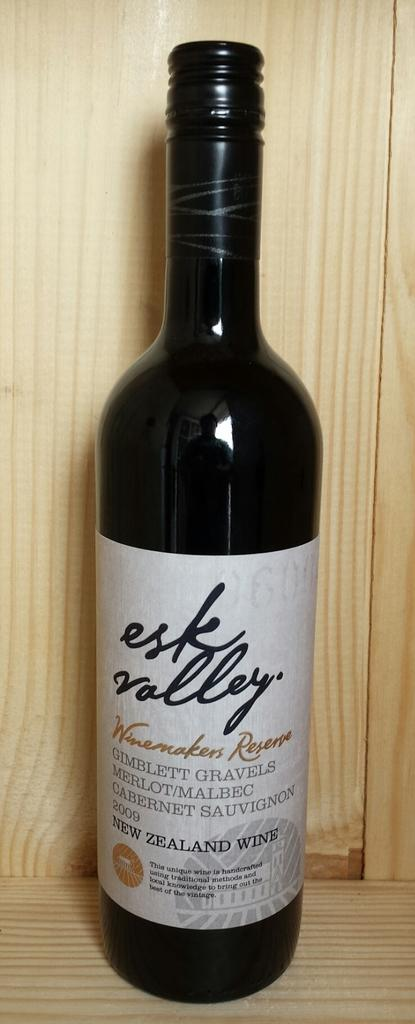<image>
Present a compact description of the photo's key features. the word esk is on a bottle that is black 